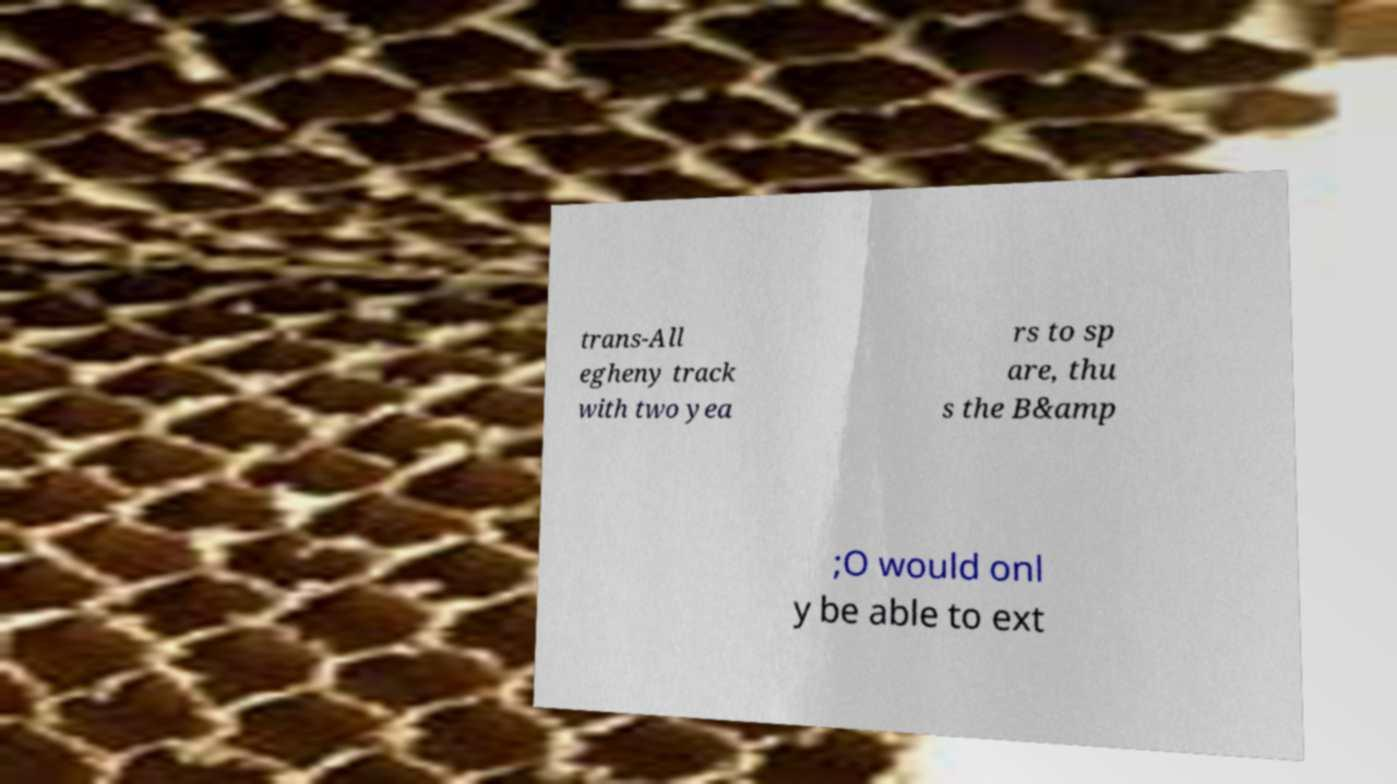Please identify and transcribe the text found in this image. trans-All egheny track with two yea rs to sp are, thu s the B&amp ;O would onl y be able to ext 